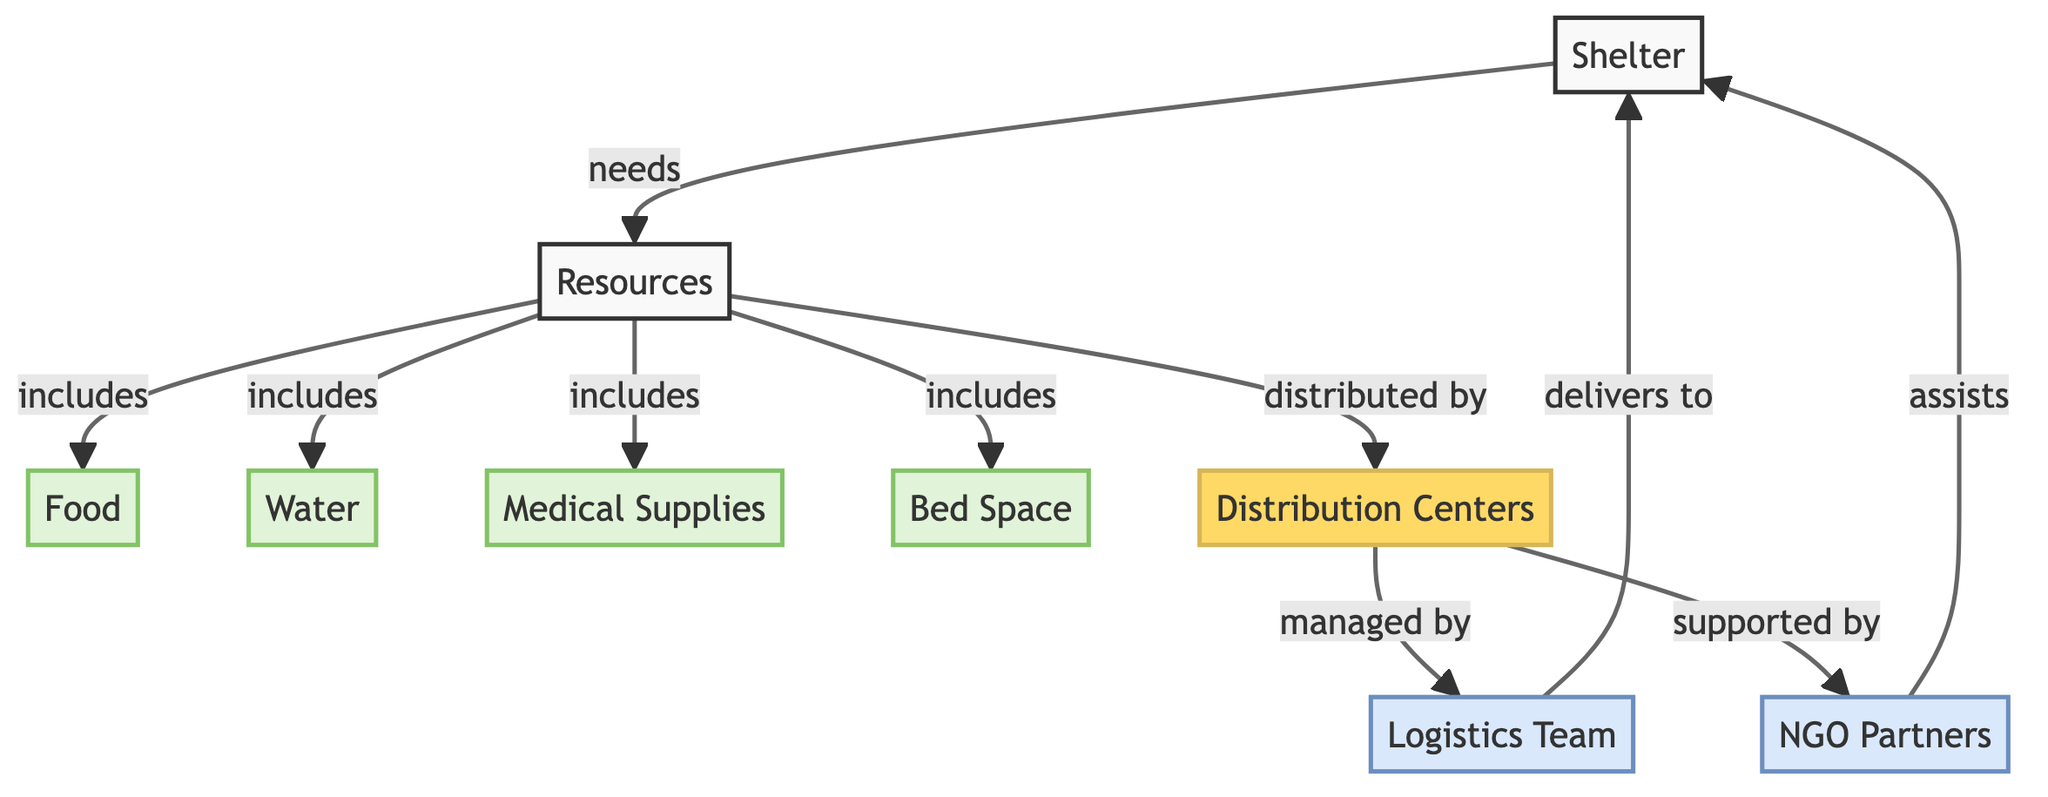What resource is included in the resources node? The diagram indicates that food is one of the resources included under the resources node.
Answer: food How many different resources are identified in this diagram? By analyzing the resources node, we can see that there are four distinct resources listed: food, water, medical supplies, and bed space.
Answer: 4 What do distribution centers do? The distribution centers are responsible for the distribution of various resources needed by the shelter, as indicated by the arrow labeled "distributed by."
Answer: distribute resources Which team manages the distribution centers? According to the diagram, the logistics team manages the distribution centers as shown by the connection labeled "managed by."
Answer: logistics team What is the relationship between the logistics team and the shelter? The logistics team delivers supplies to the shelter, as indicated by the arrow labeled "delivers to."
Answer: delivers to Who assists the shelter in this resource allocation process? The diagram indicates that NGO partners assist the shelter, as shown by the connection labeled "assists."
Answer: NGO partners What role does the resources node serve in relation to the shelter? The resources node fulfills the needs of the shelter, as depicted by the arrow labeled "needs."
Answer: fulfills needs What is the primary function of the resources according to the diagram? The resources are specified to include food, water, medical supplies, and bed space, signifying that they are essential supplies needed for shelters.
Answer: essential supplies How many teams are involved in the distribution process as per the diagram? The diagram identifies two teams involved in the distribution process: the logistics team and the NGO partners.
Answer: 2 